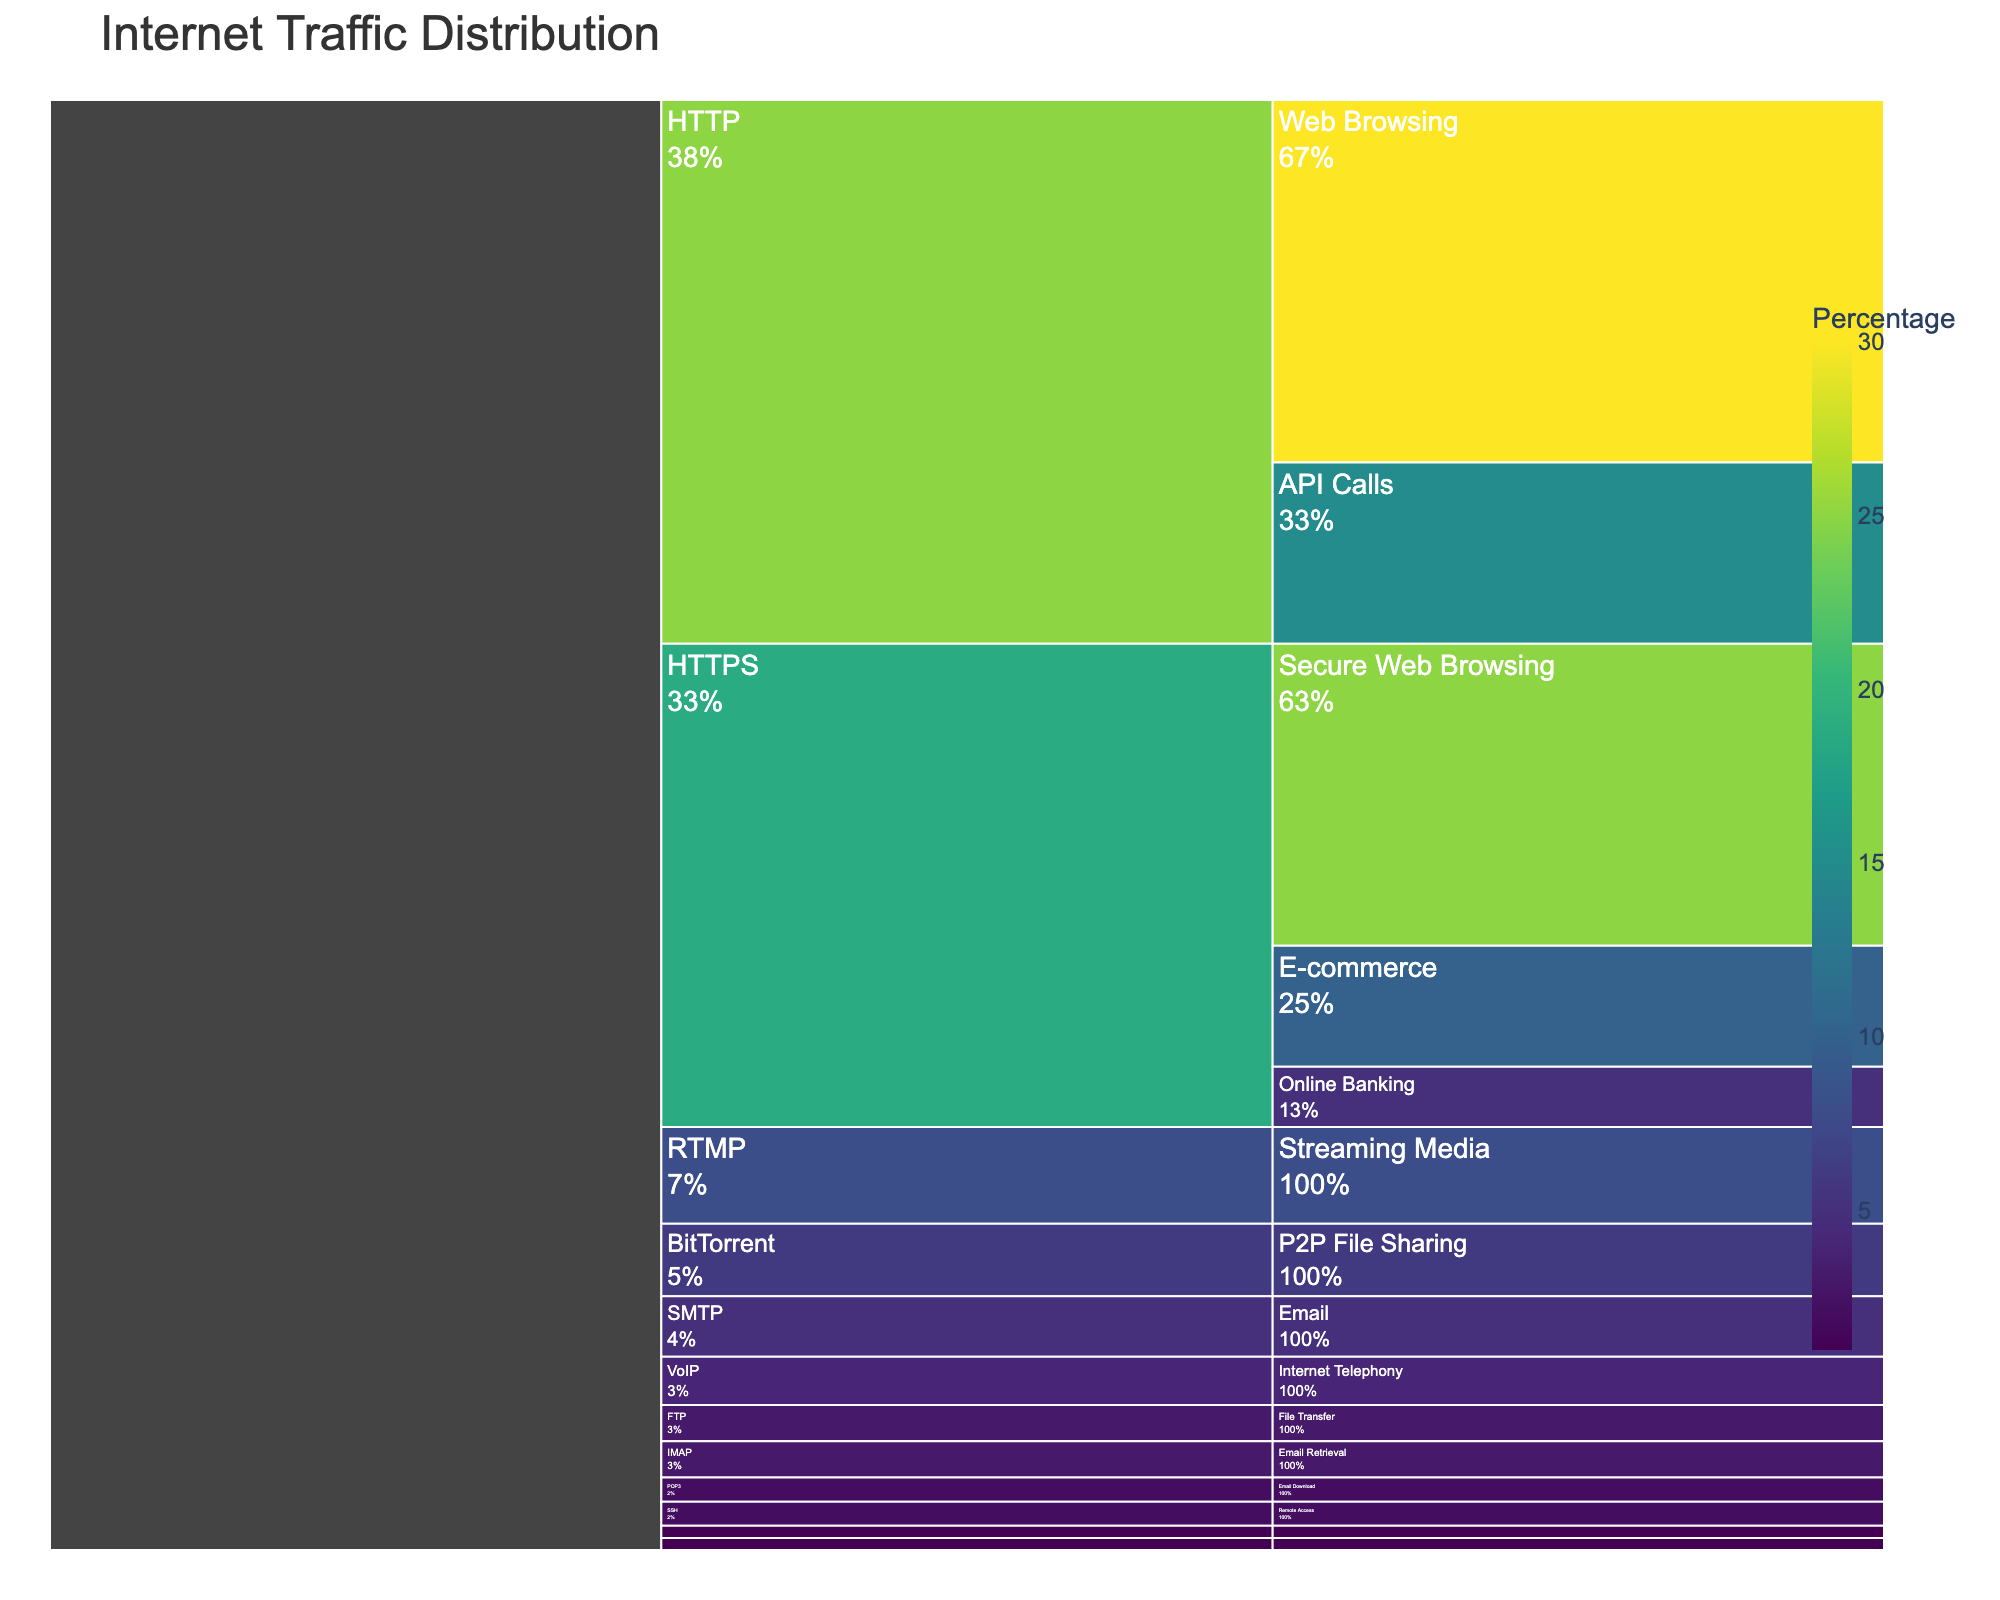What is the title of the figure? The title of the figure is typically displayed at the top. It summarizes what the chart is about. By looking at the figure, you can identify the title displayed prominently.
Answer: Internet Traffic Distribution Which protocol has the highest percentage of traffic? The hierarchical structure of the Icicle chart allows you to see the contribution of each protocol to the overall traffic. The protocol with the largest segment or bar represents the highest percentage.
Answer: HTTP What is the combined percentage of traffic for HTTPS? HTTPS has multiple services under it: Secure Web Browsing (25%), Online Banking (5%), and E-commerce (10%). Adding these together will give the total percentage for HTTPS.
Answer: 40% Which service has the smallest percentage under HTTP? By looking under the HTTP protocol, compare the sizes of the services (Web Browsing, API Calls) and identify the smallest one.
Answer: API Calls Is the percentage of Streaming Media higher or lower than that of Email? Compare the percentage for Streaming Media (8%) with the combined percentage of Email services (SMTP 5%, IMAP 3%, POP3 2%), totaling 10%.
Answer: Lower What is the percentage difference between P2P File Sharing and Internet Telephony? The percentage of BitTorrent (P2P File Sharing) is 6% and VoIP (Internet Telephony) is 4%. Subtract to find the difference.
Answer: 2% How many services have a traffic percentage less than 5%? Identify all services and count those with percentages less than 5%: Online Banking (5%), IMAP (3%), POP3 (2%), FTP (3%), SSH (2%), DNS (1%), MQTT (1%).
Answer: 6 Which protocol contributes the least to the total traffic? The protocol with the smallest combined service percentages will have the least total traffic. Identify this by summing up percentages for each protocol.
Answer: DNS What is the sum of traffic percentages for all Email-related services? Add the percentages for all services related to Email: SMTP (5%), IMAP (3%), and POP3 (2%).
Answer: 10% How can you tell the importance of Streaming Media visually? The size of each service's segment visually indicates its importance. Larger segments represent higher percentages of traffic. Hence, Streaming Media's segment size signifies its relevance.
Answer: Its size in the chart 